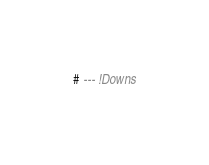Convert code to text. <code><loc_0><loc_0><loc_500><loc_500><_SQL_>
# --- !Downs
</code> 